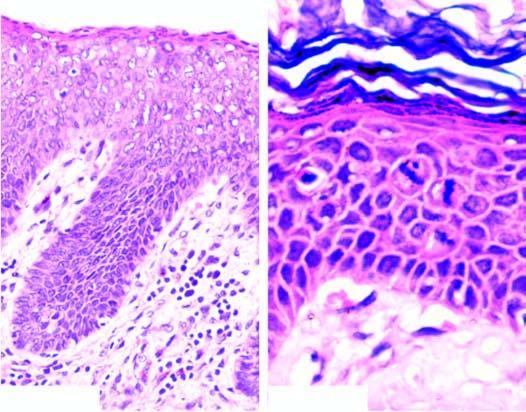s there hyperkeratosis, parakeratosis, acanthosis, koilocytosis and presence of atypical anaplastic cells throughout the entire thickness of the epithelium?
Answer the question using a single word or phrase. Yes 